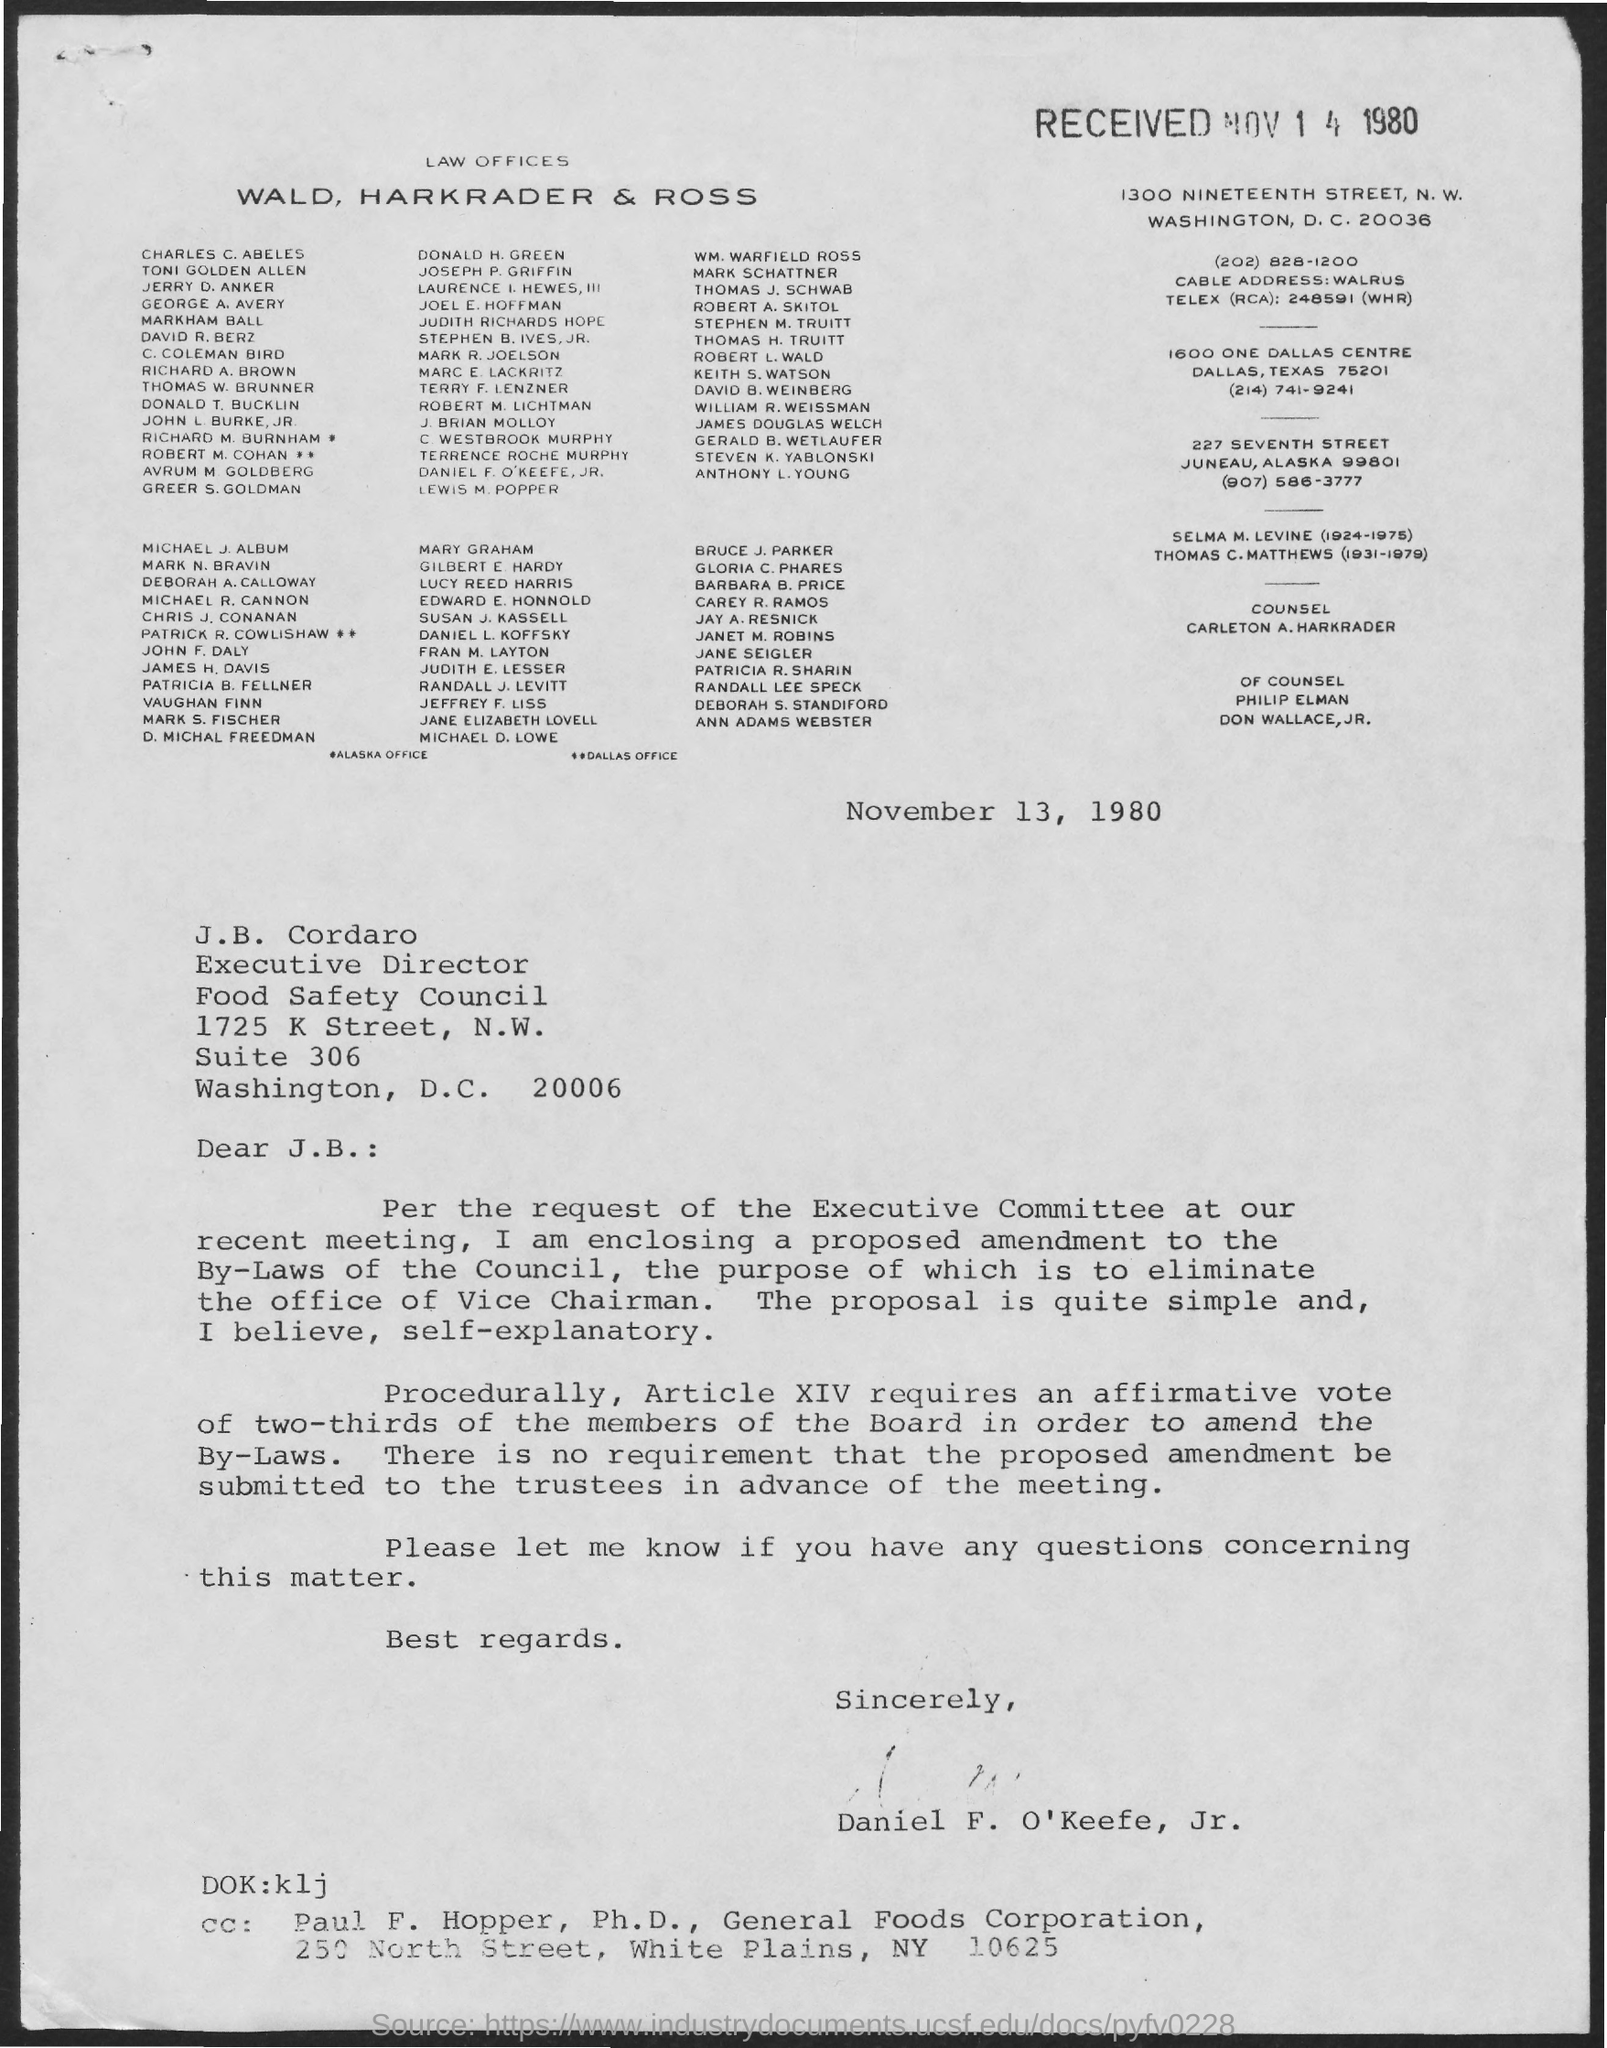When is the letter dated?
Provide a short and direct response. November 13,  1980. 